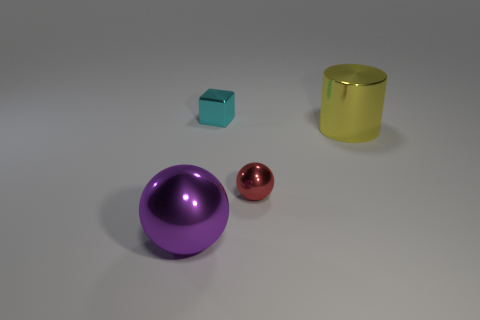Add 4 purple objects. How many objects exist? 8 Subtract all cylinders. How many objects are left? 3 Subtract 1 purple spheres. How many objects are left? 3 Subtract all large balls. Subtract all small objects. How many objects are left? 1 Add 4 cylinders. How many cylinders are left? 5 Add 2 yellow metal cylinders. How many yellow metal cylinders exist? 3 